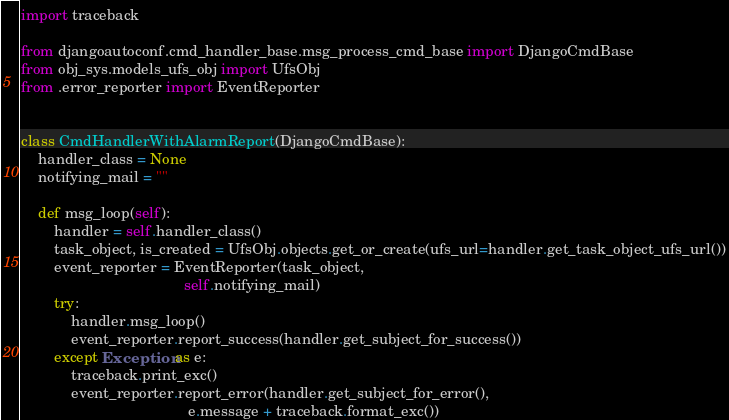<code> <loc_0><loc_0><loc_500><loc_500><_Python_>import traceback

from djangoautoconf.cmd_handler_base.msg_process_cmd_base import DjangoCmdBase
from obj_sys.models_ufs_obj import UfsObj
from .error_reporter import EventReporter


class CmdHandlerWithAlarmReport(DjangoCmdBase):
    handler_class = None
    notifying_mail = ""

    def msg_loop(self):
        handler = self.handler_class()
        task_object, is_created = UfsObj.objects.get_or_create(ufs_url=handler.get_task_object_ufs_url())
        event_reporter = EventReporter(task_object,
                                       self.notifying_mail)
        try:
            handler.msg_loop()
            event_reporter.report_success(handler.get_subject_for_success())
        except Exception as e:
            traceback.print_exc()
            event_reporter.report_error(handler.get_subject_for_error(),
                                        e.message + traceback.format_exc())


</code> 